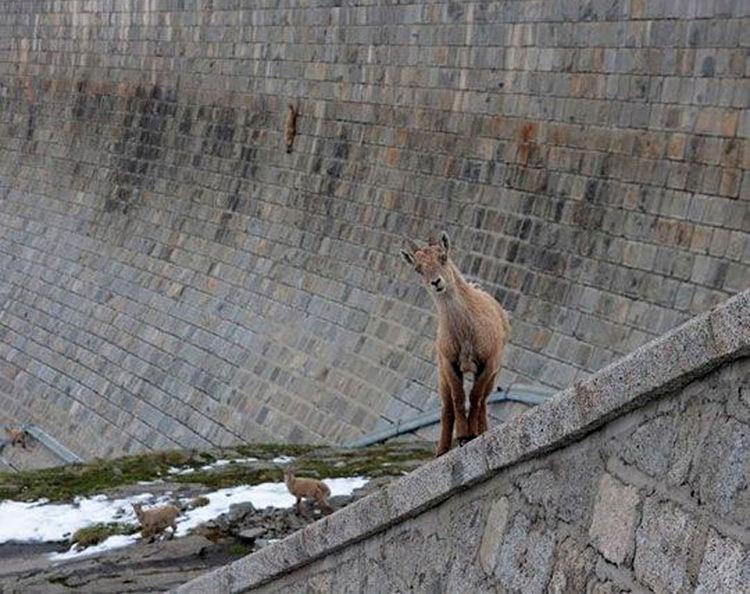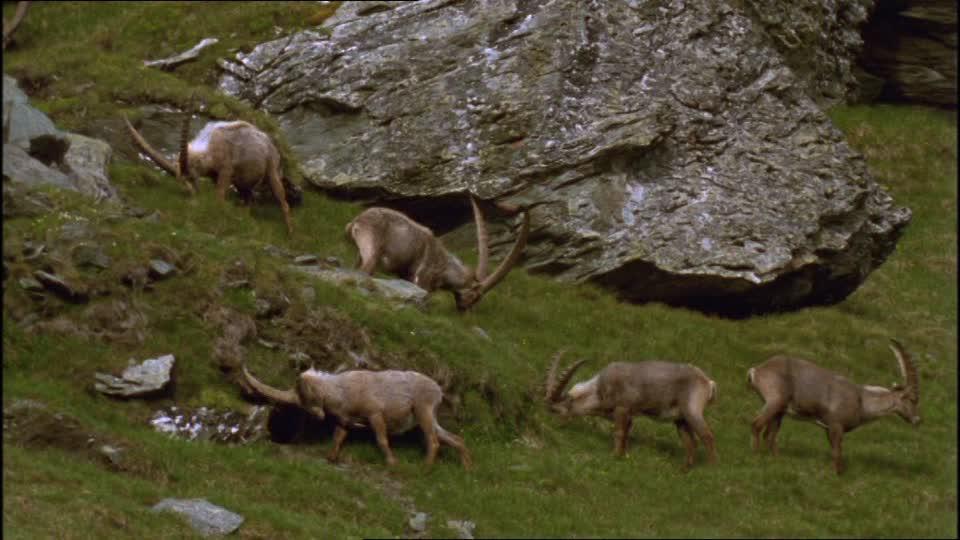The first image is the image on the left, the second image is the image on the right. For the images shown, is this caption "the image on the lft contains a single antelope" true? Answer yes or no. Yes. 